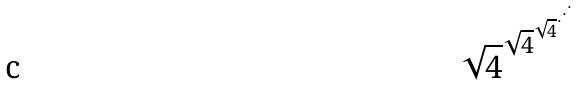Convert formula to latex. <formula><loc_0><loc_0><loc_500><loc_500>\sqrt { 4 } ^ { \sqrt { 4 } ^ { \sqrt { 4 } ^ { \cdot ^ { \cdot ^ { \cdot } } } } }</formula> 